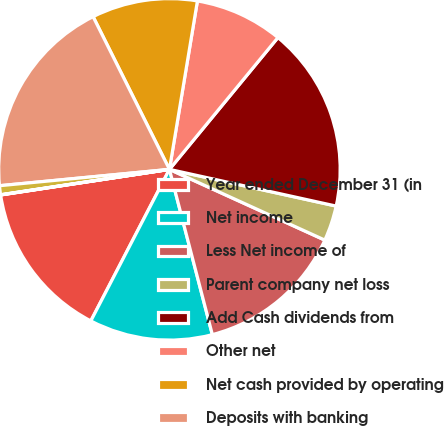<chart> <loc_0><loc_0><loc_500><loc_500><pie_chart><fcel>Year ended December 31 (in<fcel>Net income<fcel>Less Net income of<fcel>Parent company net loss<fcel>Add Cash dividends from<fcel>Other net<fcel>Net cash provided by operating<fcel>Deposits with banking<fcel>Securities purchased under<fcel>Loans<nl><fcel>14.99%<fcel>11.66%<fcel>14.16%<fcel>3.35%<fcel>17.49%<fcel>8.34%<fcel>10.0%<fcel>19.15%<fcel>0.85%<fcel>0.02%<nl></chart> 